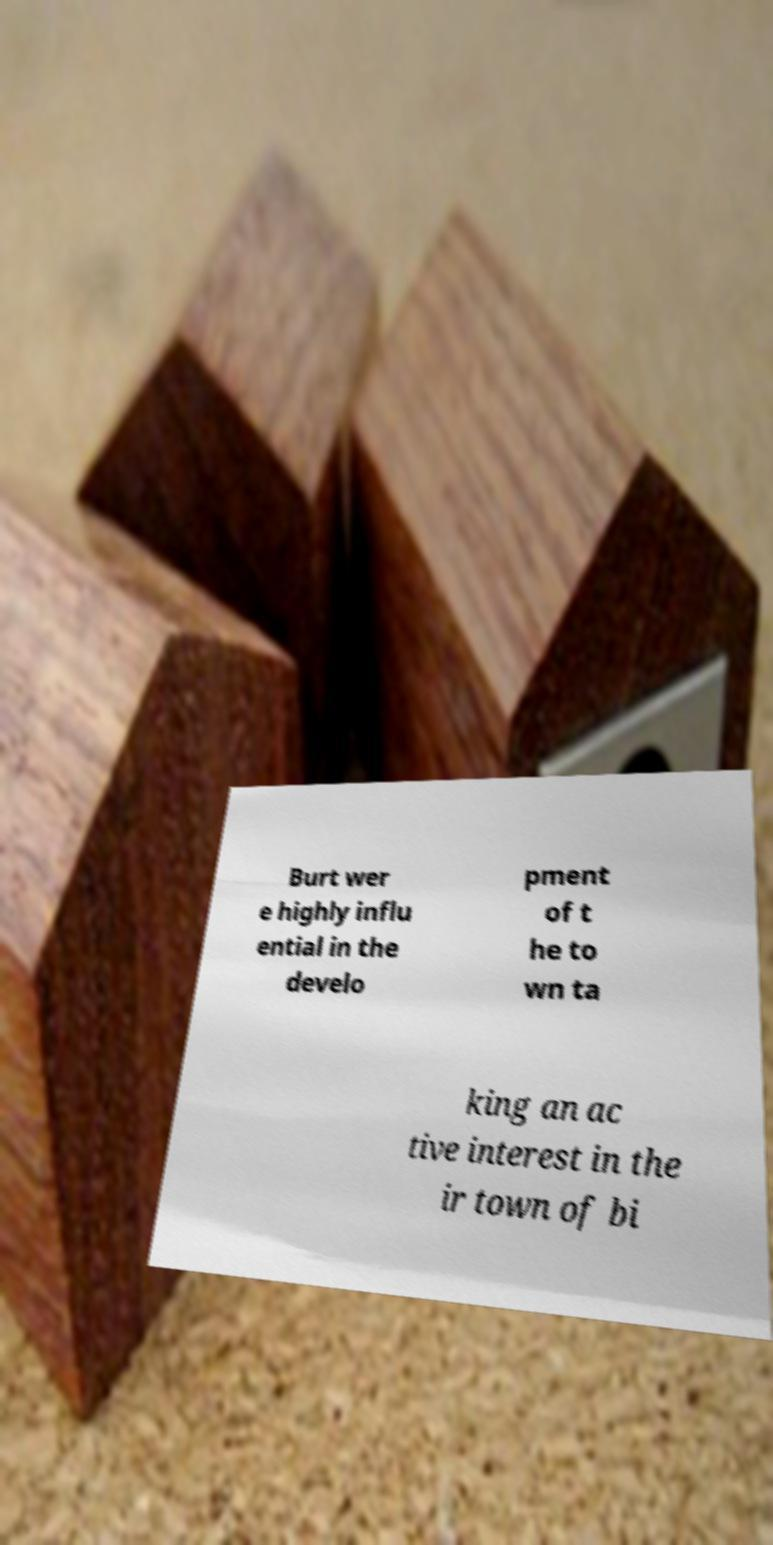Can you accurately transcribe the text from the provided image for me? Burt wer e highly influ ential in the develo pment of t he to wn ta king an ac tive interest in the ir town of bi 